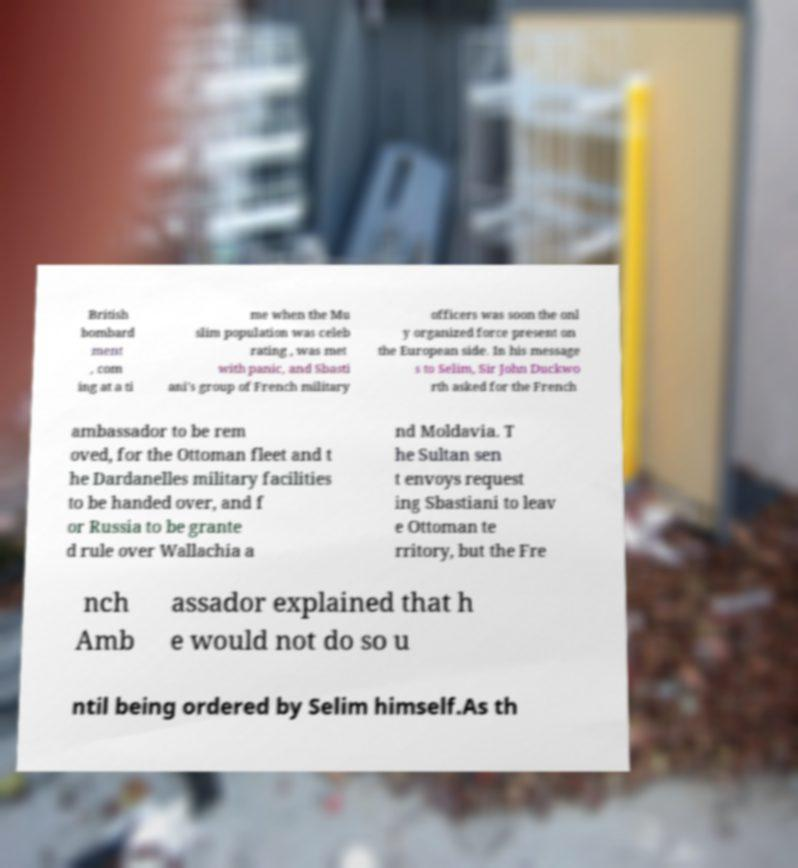Could you assist in decoding the text presented in this image and type it out clearly? British bombard ment , com ing at a ti me when the Mu slim population was celeb rating , was met with panic, and Sbasti ani's group of French military officers was soon the onl y organized force present on the European side. In his message s to Selim, Sir John Duckwo rth asked for the French ambassador to be rem oved, for the Ottoman fleet and t he Dardanelles military facilities to be handed over, and f or Russia to be grante d rule over Wallachia a nd Moldavia. T he Sultan sen t envoys request ing Sbastiani to leav e Ottoman te rritory, but the Fre nch Amb assador explained that h e would not do so u ntil being ordered by Selim himself.As th 